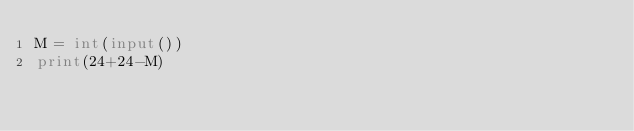Convert code to text. <code><loc_0><loc_0><loc_500><loc_500><_Python_>M = int(input())
print(24+24-M)</code> 